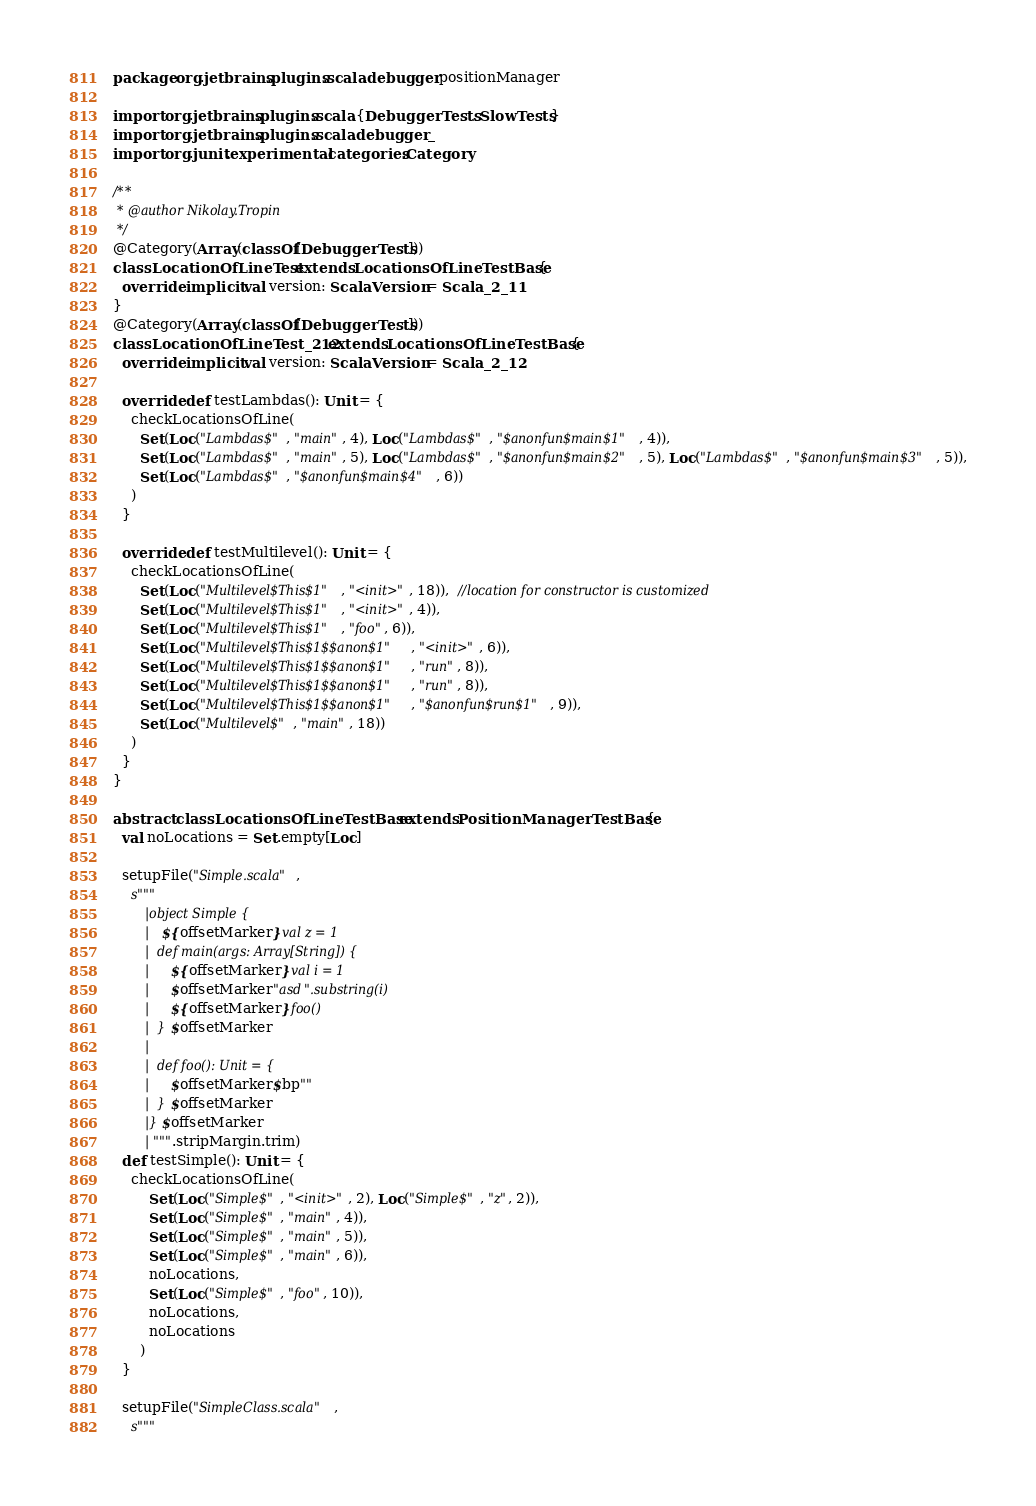Convert code to text. <code><loc_0><loc_0><loc_500><loc_500><_Scala_>package org.jetbrains.plugins.scala.debugger.positionManager

import org.jetbrains.plugins.scala.{DebuggerTests, SlowTests}
import org.jetbrains.plugins.scala.debugger._
import org.junit.experimental.categories.Category

/**
 * @author Nikolay.Tropin
 */
@Category(Array(classOf[DebuggerTests]))
class LocationOfLineTest extends LocationsOfLineTestBase {
  override implicit val version: ScalaVersion = Scala_2_11
}
@Category(Array(classOf[DebuggerTests]))
class LocationOfLineTest_212 extends LocationsOfLineTestBase {
  override implicit val version: ScalaVersion = Scala_2_12

  override def testLambdas(): Unit = {
    checkLocationsOfLine(
      Set(Loc("Lambdas$", "main", 4), Loc("Lambdas$", "$anonfun$main$1", 4)),
      Set(Loc("Lambdas$", "main", 5), Loc("Lambdas$", "$anonfun$main$2", 5), Loc("Lambdas$", "$anonfun$main$3", 5)),
      Set(Loc("Lambdas$", "$anonfun$main$4", 6))
    )
  }

  override def testMultilevel(): Unit = {
    checkLocationsOfLine(
      Set(Loc("Multilevel$This$1", "<init>", 18)),  //location for constructor is customized
      Set(Loc("Multilevel$This$1", "<init>", 4)),
      Set(Loc("Multilevel$This$1", "foo", 6)),
      Set(Loc("Multilevel$This$1$$anon$1", "<init>", 6)),
      Set(Loc("Multilevel$This$1$$anon$1", "run", 8)),
      Set(Loc("Multilevel$This$1$$anon$1", "run", 8)),
      Set(Loc("Multilevel$This$1$$anon$1", "$anonfun$run$1", 9)),
      Set(Loc("Multilevel$", "main", 18))
    )
  }
}

abstract class LocationsOfLineTestBase extends PositionManagerTestBase {
  val noLocations = Set.empty[Loc]

  setupFile("Simple.scala",
    s"""
        |object Simple {
        |  ${offsetMarker}val z = 1
        |  def main(args: Array[String]) {
        |    ${offsetMarker}val i = 1
        |    $offsetMarker"asd".substring(i)
        |    ${offsetMarker}foo()
        |  }$offsetMarker
        |
        |  def foo(): Unit = {
        |    $offsetMarker$bp""
        |  }$offsetMarker
        |}$offsetMarker
        |""".stripMargin.trim)
  def testSimple(): Unit = {
    checkLocationsOfLine(
        Set(Loc("Simple$", "<init>", 2), Loc("Simple$", "z", 2)),
        Set(Loc("Simple$", "main", 4)),
        Set(Loc("Simple$", "main", 5)),
        Set(Loc("Simple$", "main", 6)),
        noLocations,
        Set(Loc("Simple$", "foo", 10)),
        noLocations,
        noLocations
      )
  }

  setupFile("SimpleClass.scala",
    s"""</code> 